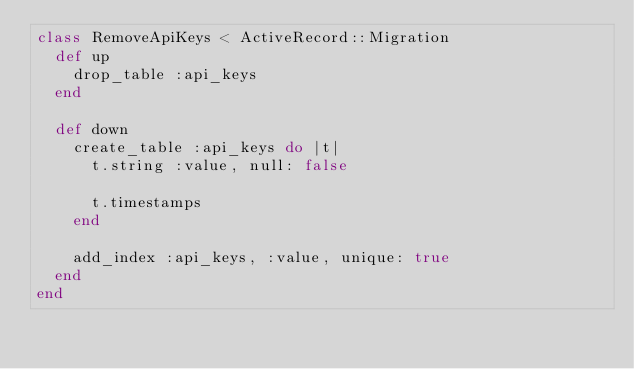Convert code to text. <code><loc_0><loc_0><loc_500><loc_500><_Ruby_>class RemoveApiKeys < ActiveRecord::Migration
  def up
    drop_table :api_keys
  end

  def down
    create_table :api_keys do |t|
      t.string :value, null: false

      t.timestamps
    end

    add_index :api_keys, :value, unique: true
  end
end
</code> 